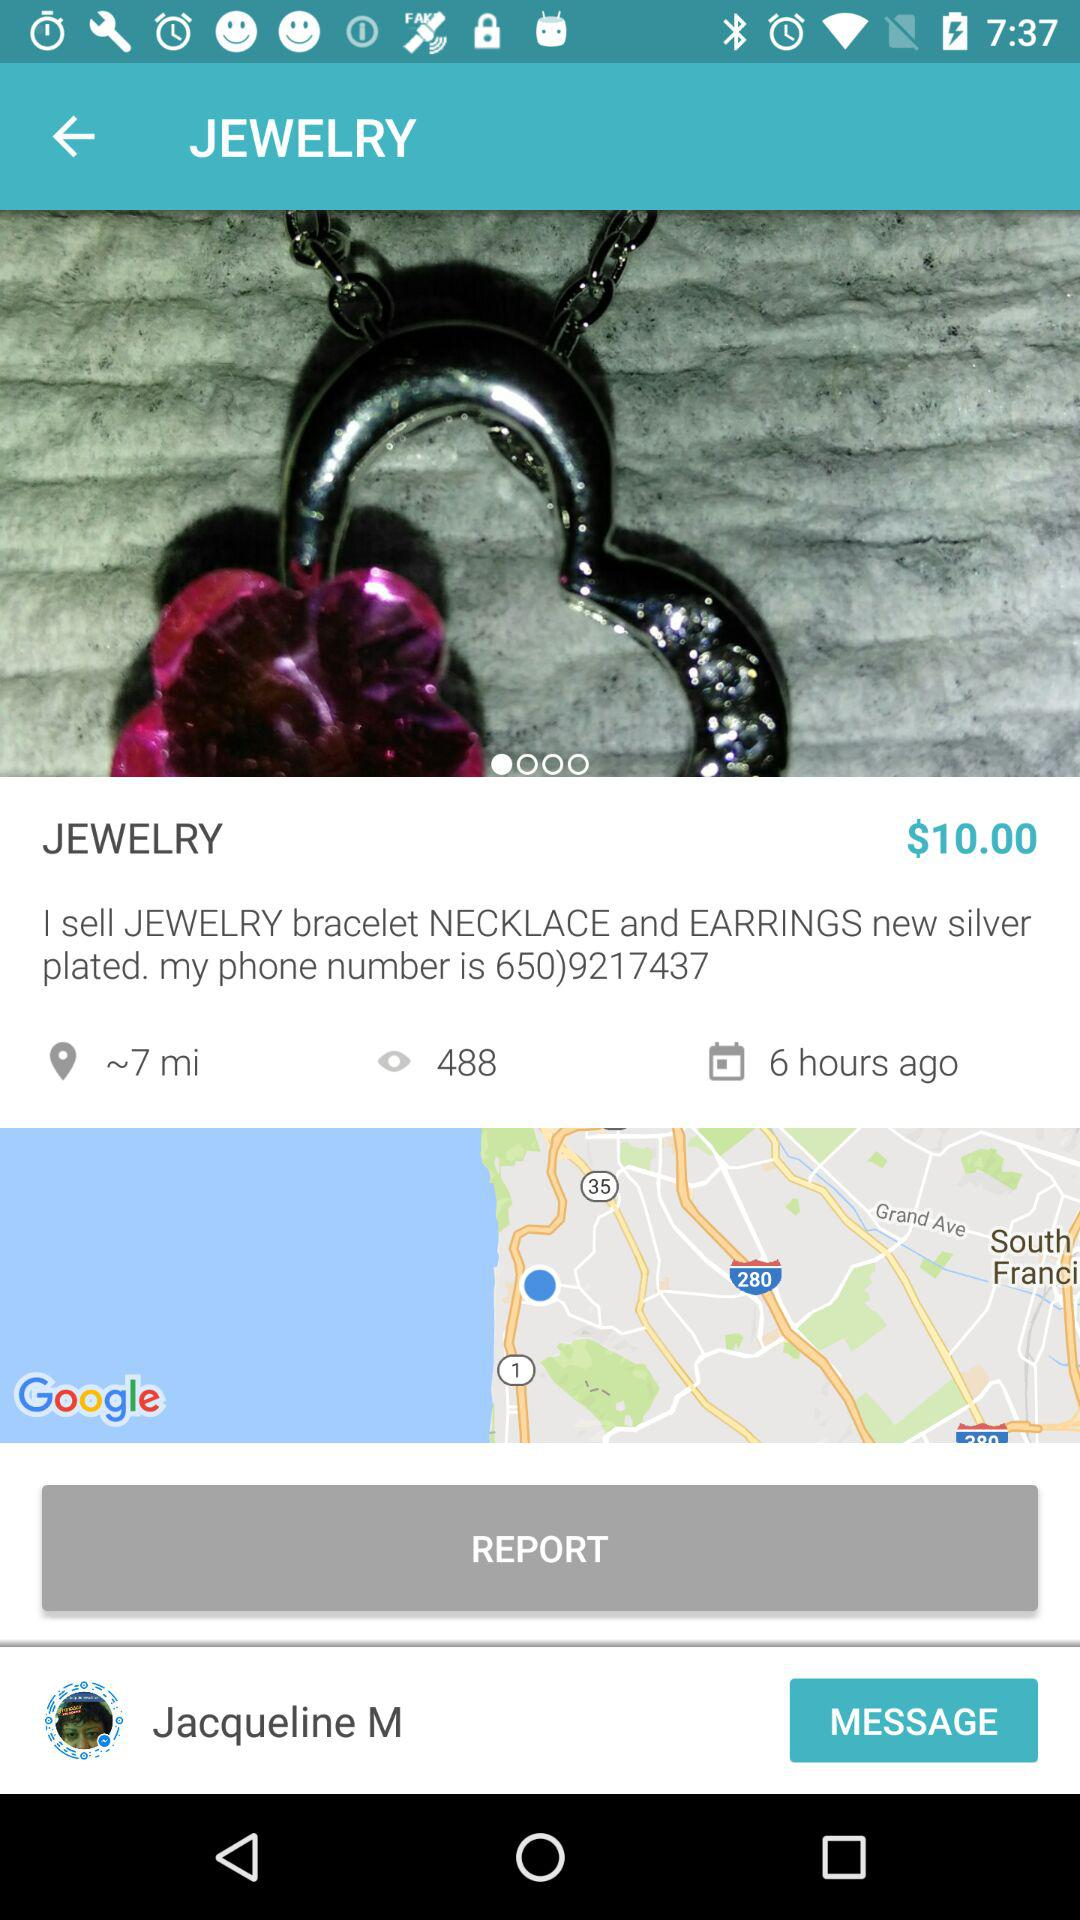When was the item posted? The item was posted 6 hours ago. 